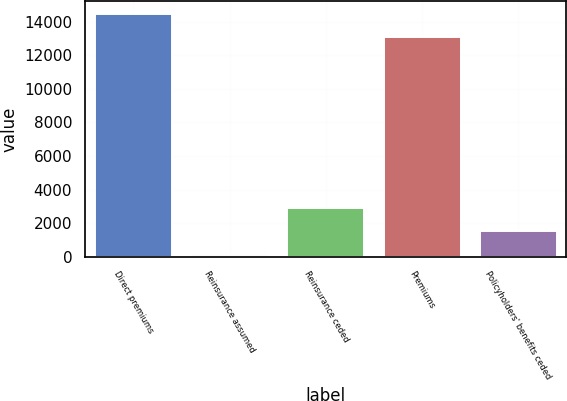Convert chart to OTSL. <chart><loc_0><loc_0><loc_500><loc_500><bar_chart><fcel>Direct premiums<fcel>Reinsurance assumed<fcel>Reinsurance ceded<fcel>Premiums<fcel>Policyholders' benefits ceded<nl><fcel>14483.4<fcel>133<fcel>2875.8<fcel>13112<fcel>1504.4<nl></chart> 